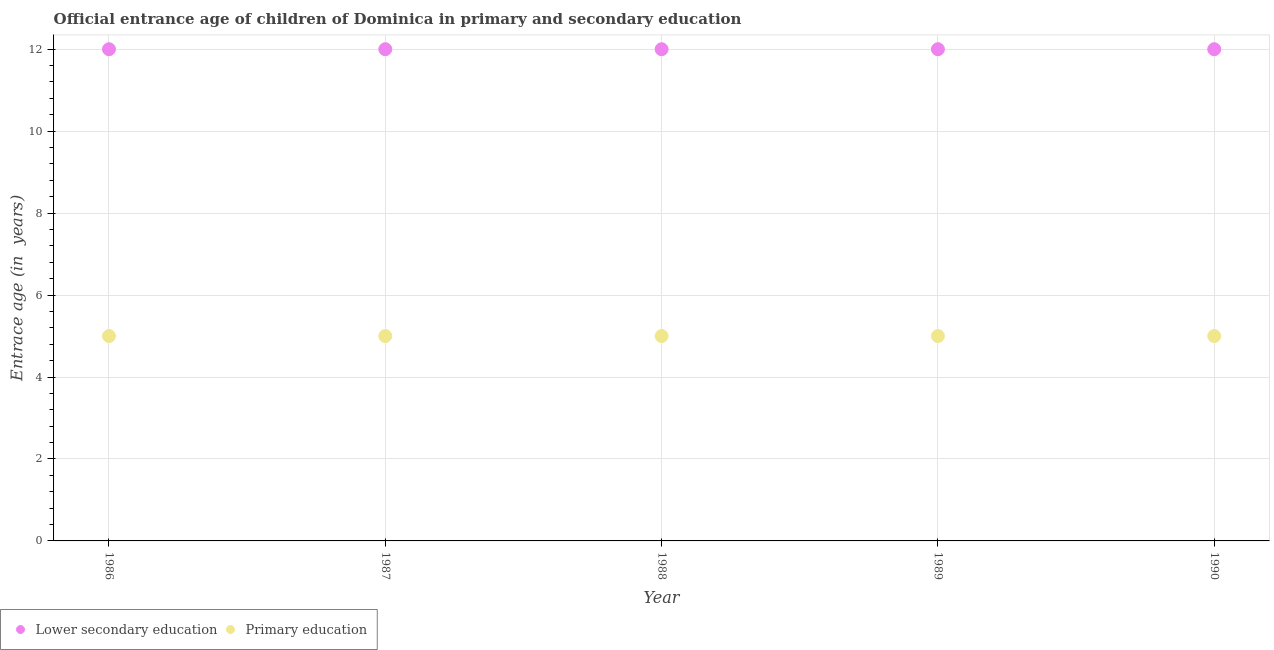Is the number of dotlines equal to the number of legend labels?
Make the answer very short. Yes. What is the entrance age of children in lower secondary education in 1990?
Offer a very short reply. 12. Across all years, what is the maximum entrance age of chiildren in primary education?
Offer a terse response. 5. Across all years, what is the minimum entrance age of chiildren in primary education?
Give a very brief answer. 5. In which year was the entrance age of children in lower secondary education minimum?
Keep it short and to the point. 1986. What is the total entrance age of chiildren in primary education in the graph?
Your answer should be compact. 25. What is the difference between the entrance age of children in lower secondary education in 1989 and the entrance age of chiildren in primary education in 1987?
Offer a terse response. 7. In the year 1987, what is the difference between the entrance age of children in lower secondary education and entrance age of chiildren in primary education?
Ensure brevity in your answer.  7. In how many years, is the entrance age of chiildren in primary education greater than 4 years?
Your answer should be very brief. 5. Is the entrance age of children in lower secondary education in 1987 less than that in 1989?
Your response must be concise. No. Is the difference between the entrance age of chiildren in primary education in 1987 and 1988 greater than the difference between the entrance age of children in lower secondary education in 1987 and 1988?
Make the answer very short. No. What is the difference between the highest and the second highest entrance age of chiildren in primary education?
Your answer should be very brief. 0. In how many years, is the entrance age of chiildren in primary education greater than the average entrance age of chiildren in primary education taken over all years?
Offer a very short reply. 0. Does the entrance age of chiildren in primary education monotonically increase over the years?
Offer a terse response. No. Is the entrance age of children in lower secondary education strictly greater than the entrance age of chiildren in primary education over the years?
Your answer should be very brief. Yes. Is the entrance age of chiildren in primary education strictly less than the entrance age of children in lower secondary education over the years?
Keep it short and to the point. Yes. What is the difference between two consecutive major ticks on the Y-axis?
Make the answer very short. 2. Does the graph contain any zero values?
Provide a succinct answer. No. Does the graph contain grids?
Your answer should be compact. Yes. Where does the legend appear in the graph?
Offer a terse response. Bottom left. How are the legend labels stacked?
Make the answer very short. Horizontal. What is the title of the graph?
Offer a terse response. Official entrance age of children of Dominica in primary and secondary education. Does "Mobile cellular" appear as one of the legend labels in the graph?
Make the answer very short. No. What is the label or title of the X-axis?
Make the answer very short. Year. What is the label or title of the Y-axis?
Your answer should be compact. Entrace age (in  years). What is the Entrace age (in  years) of Lower secondary education in 1986?
Provide a short and direct response. 12. What is the Entrace age (in  years) of Primary education in 1986?
Offer a very short reply. 5. What is the Entrace age (in  years) in Lower secondary education in 1989?
Your response must be concise. 12. What is the Entrace age (in  years) of Primary education in 1989?
Provide a succinct answer. 5. What is the Entrace age (in  years) of Lower secondary education in 1990?
Your answer should be very brief. 12. What is the Entrace age (in  years) in Primary education in 1990?
Ensure brevity in your answer.  5. What is the difference between the Entrace age (in  years) of Primary education in 1986 and that in 1987?
Your answer should be very brief. 0. What is the difference between the Entrace age (in  years) of Lower secondary education in 1986 and that in 1988?
Provide a short and direct response. 0. What is the difference between the Entrace age (in  years) in Primary education in 1986 and that in 1988?
Provide a short and direct response. 0. What is the difference between the Entrace age (in  years) of Primary education in 1986 and that in 1989?
Offer a very short reply. 0. What is the difference between the Entrace age (in  years) of Lower secondary education in 1988 and that in 1989?
Offer a terse response. 0. What is the difference between the Entrace age (in  years) of Primary education in 1988 and that in 1990?
Make the answer very short. 0. What is the difference between the Entrace age (in  years) of Lower secondary education in 1989 and that in 1990?
Your response must be concise. 0. What is the difference between the Entrace age (in  years) of Primary education in 1989 and that in 1990?
Your answer should be compact. 0. What is the difference between the Entrace age (in  years) in Lower secondary education in 1986 and the Entrace age (in  years) in Primary education in 1987?
Keep it short and to the point. 7. What is the difference between the Entrace age (in  years) of Lower secondary education in 1986 and the Entrace age (in  years) of Primary education in 1988?
Offer a terse response. 7. What is the difference between the Entrace age (in  years) in Lower secondary education in 1986 and the Entrace age (in  years) in Primary education in 1989?
Make the answer very short. 7. What is the difference between the Entrace age (in  years) in Lower secondary education in 1987 and the Entrace age (in  years) in Primary education in 1989?
Make the answer very short. 7. What is the difference between the Entrace age (in  years) in Lower secondary education in 1988 and the Entrace age (in  years) in Primary education in 1990?
Your answer should be compact. 7. What is the difference between the Entrace age (in  years) of Lower secondary education in 1989 and the Entrace age (in  years) of Primary education in 1990?
Make the answer very short. 7. What is the average Entrace age (in  years) in Lower secondary education per year?
Ensure brevity in your answer.  12. What is the average Entrace age (in  years) in Primary education per year?
Provide a short and direct response. 5. In the year 1987, what is the difference between the Entrace age (in  years) in Lower secondary education and Entrace age (in  years) in Primary education?
Provide a succinct answer. 7. In the year 1988, what is the difference between the Entrace age (in  years) in Lower secondary education and Entrace age (in  years) in Primary education?
Offer a terse response. 7. In the year 1990, what is the difference between the Entrace age (in  years) of Lower secondary education and Entrace age (in  years) of Primary education?
Your answer should be very brief. 7. What is the ratio of the Entrace age (in  years) in Lower secondary education in 1986 to that in 1987?
Provide a succinct answer. 1. What is the ratio of the Entrace age (in  years) of Primary education in 1986 to that in 1987?
Ensure brevity in your answer.  1. What is the ratio of the Entrace age (in  years) in Primary education in 1986 to that in 1988?
Give a very brief answer. 1. What is the ratio of the Entrace age (in  years) of Lower secondary education in 1986 to that in 1989?
Your answer should be very brief. 1. What is the ratio of the Entrace age (in  years) of Primary education in 1986 to that in 1990?
Your answer should be compact. 1. What is the ratio of the Entrace age (in  years) in Lower secondary education in 1987 to that in 1988?
Your answer should be compact. 1. What is the ratio of the Entrace age (in  years) in Primary education in 1987 to that in 1988?
Give a very brief answer. 1. What is the ratio of the Entrace age (in  years) of Lower secondary education in 1987 to that in 1989?
Your answer should be compact. 1. What is the ratio of the Entrace age (in  years) in Lower secondary education in 1987 to that in 1990?
Give a very brief answer. 1. What is the ratio of the Entrace age (in  years) of Lower secondary education in 1988 to that in 1990?
Give a very brief answer. 1. What is the difference between the highest and the second highest Entrace age (in  years) in Lower secondary education?
Provide a short and direct response. 0. What is the difference between the highest and the second highest Entrace age (in  years) in Primary education?
Offer a very short reply. 0. What is the difference between the highest and the lowest Entrace age (in  years) of Primary education?
Your answer should be very brief. 0. 